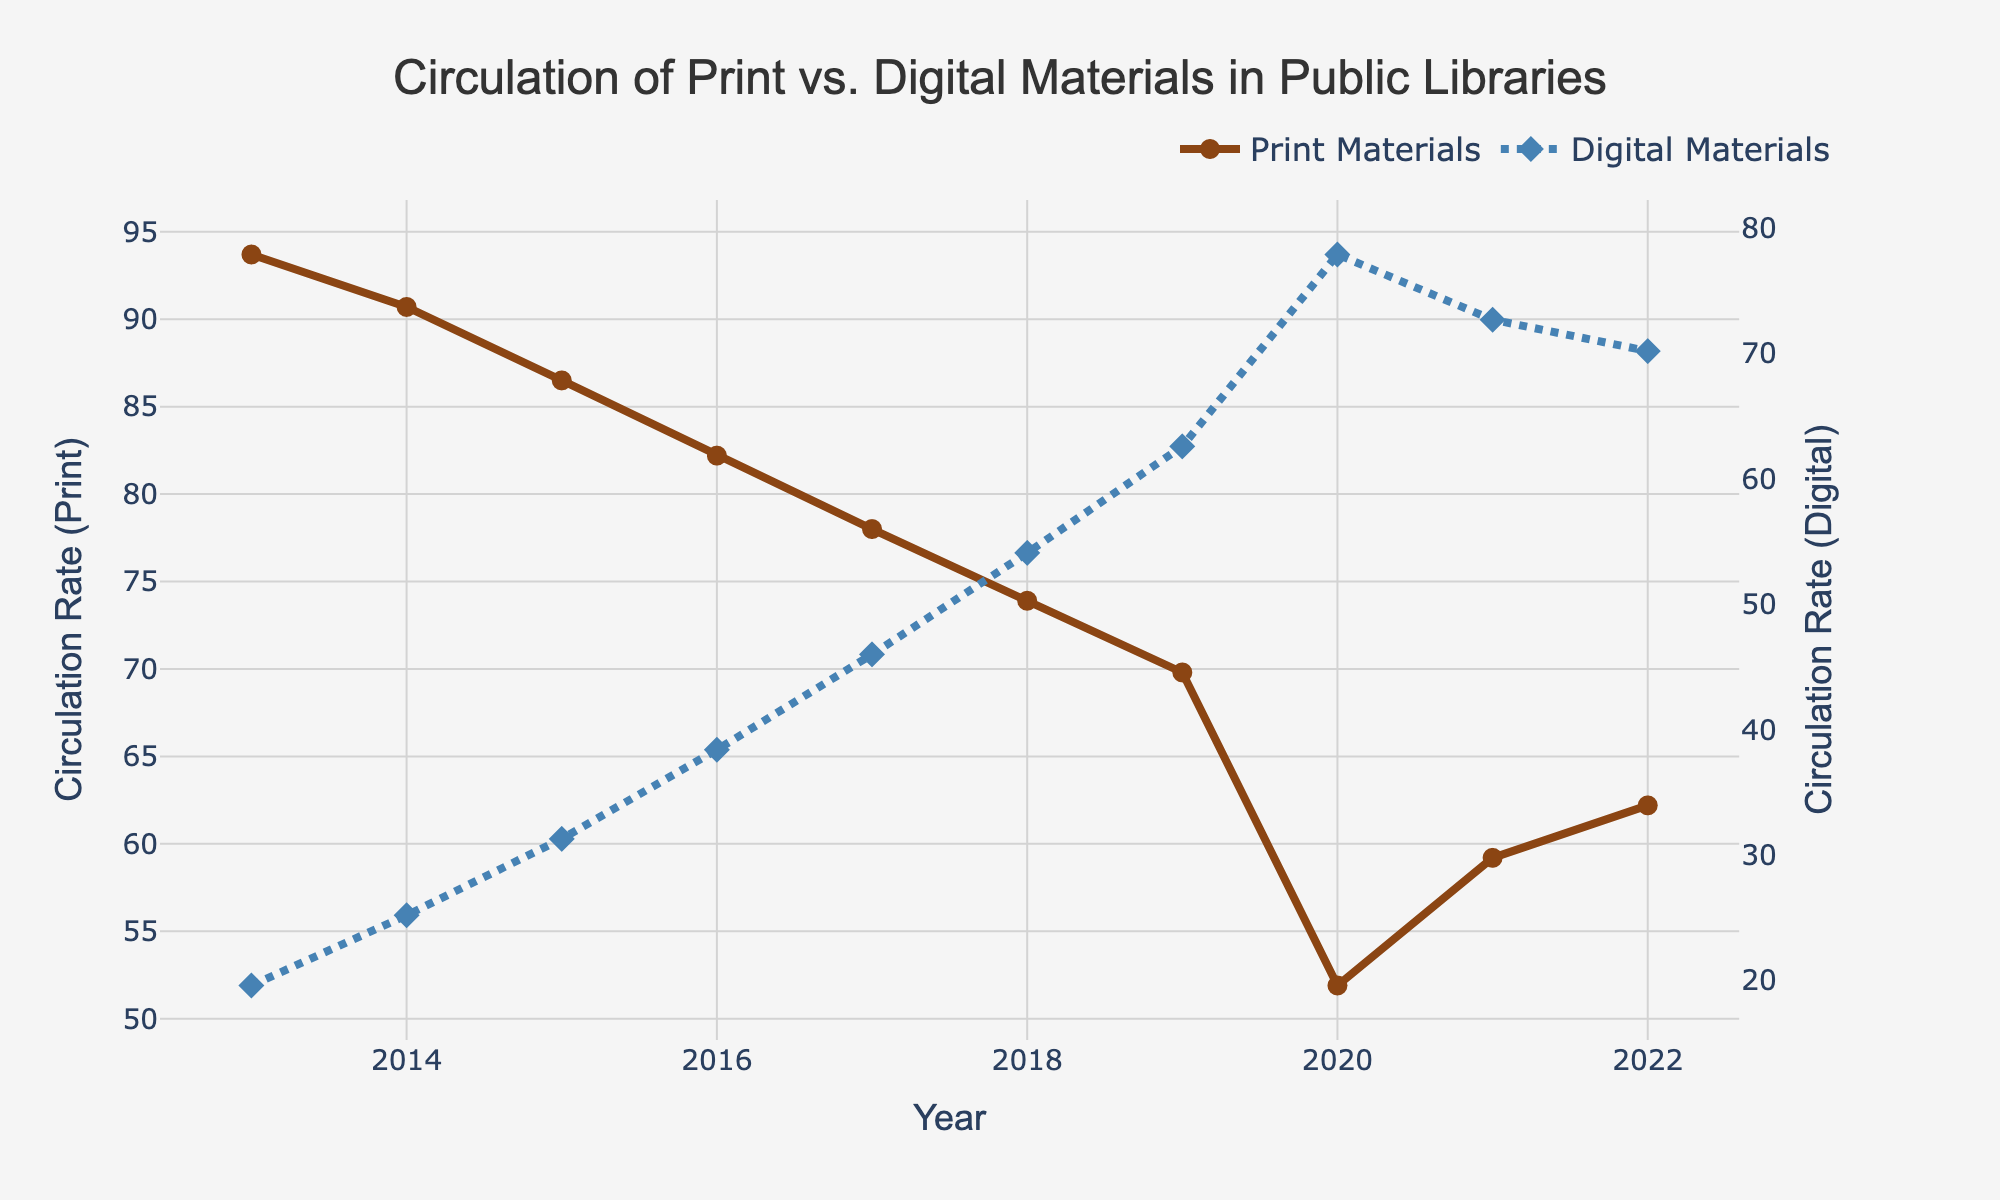What's the overall trend in the circulation rates of print materials over the decade? To determine the trend, look at the line representing print materials. The data starts with higher circulation rates in 2013 and shows a general decline over the years, with a significant dip in 2020, followed by a slight recovery in 2021 and 2022.
Answer: Decline How do the circulation rates of digital materials in 2022 compare to those in 2013? Check the data points for digital materials in 2022 and 2013. Digital materials start at lower circulation rates in 2013 and end at higher rates in 2022. Specifically, the circulation rate was 19.6 in 2013 and increased to 70.2 in 2022.
Answer: Higher in 2022 What is the combined circulation rate of both print and digital materials in 2020? Add the circulation rates of print materials (43.2) and digital materials (78.4) for 2020. Combined rate = 43.2 + 78.4.
Answer: 121.6 In which year did digital materials overtake print materials in circulation rates? Observe the point where the digital material line crosses above the print material line on the chart. The crossover happens around 2020.
Answer: 2020 What are the visual differences in the line styles used to represent print and digital materials? The line representing print materials is solid brown, while the lines for digital materials are blue and dashed.
Answer: Brown solid line for print, blue dashed line for digital Which type of material shows the most consistent increase in circulation rates from 2013 to 2022? Review the slopes of the lines over time. The line for digital materials has a consistent upward trend, indicating a steady increase.
Answer: Digital materials Between 2020 and 2021, which type of material saw a greater recovery in circulation rates? Compare the changes in circulation rates between these two years for both print and digital materials. Print materials recovered from 43.2 to 49.7, while digital materials decreased from 78.4 to 72.7.
Answer: Print materials What is the average circulation rate of print materials over the entire period? Sum all the annual circulation rates of print materials and divide by the number of years (10). Average = (93.7 + 90.7 + 86.5 + 82.2 + 78 + 73.9 + 68.8 + 56.3 + 59.2 + 62.2) / 10.
Answer: 75.1 How does the circulation rate of print books specifically compare to digital audiobooks in 2022? Compare the values for print books (52.1) and digital audiobooks (17.8) for 2022. Print books have a higher circulation rate.
Answer: Print books higher By how much did the circulation rate of digital audiobooks increase from 2013 to 2022? Subtract the 2013 rate (4.2) from the 2022 rate (17.8). Increase = 17.8 - 4.2.
Answer: 13.6 